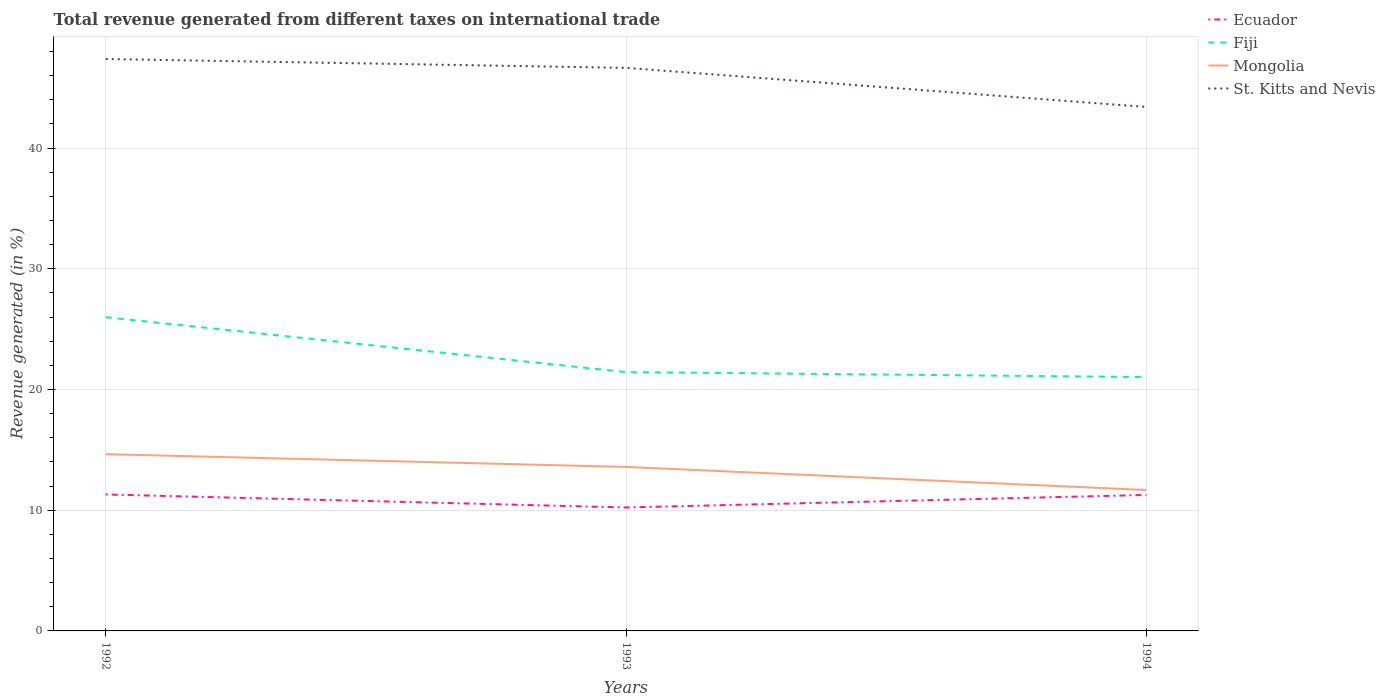How many different coloured lines are there?
Ensure brevity in your answer.  4. Does the line corresponding to St. Kitts and Nevis intersect with the line corresponding to Fiji?
Keep it short and to the point. No. Across all years, what is the maximum total revenue generated in Fiji?
Give a very brief answer. 21.03. What is the total total revenue generated in St. Kitts and Nevis in the graph?
Your answer should be compact. 3.24. What is the difference between the highest and the second highest total revenue generated in St. Kitts and Nevis?
Ensure brevity in your answer.  3.97. What is the difference between two consecutive major ticks on the Y-axis?
Your response must be concise. 10. Where does the legend appear in the graph?
Your answer should be compact. Top right. How many legend labels are there?
Give a very brief answer. 4. What is the title of the graph?
Make the answer very short. Total revenue generated from different taxes on international trade. Does "Kazakhstan" appear as one of the legend labels in the graph?
Provide a succinct answer. No. What is the label or title of the X-axis?
Offer a very short reply. Years. What is the label or title of the Y-axis?
Make the answer very short. Revenue generated (in %). What is the Revenue generated (in %) of Ecuador in 1992?
Make the answer very short. 11.3. What is the Revenue generated (in %) in Fiji in 1992?
Ensure brevity in your answer.  25.99. What is the Revenue generated (in %) in Mongolia in 1992?
Provide a succinct answer. 14.64. What is the Revenue generated (in %) in St. Kitts and Nevis in 1992?
Your response must be concise. 47.38. What is the Revenue generated (in %) of Ecuador in 1993?
Make the answer very short. 10.23. What is the Revenue generated (in %) in Fiji in 1993?
Give a very brief answer. 21.44. What is the Revenue generated (in %) in Mongolia in 1993?
Give a very brief answer. 13.59. What is the Revenue generated (in %) of St. Kitts and Nevis in 1993?
Your answer should be very brief. 46.64. What is the Revenue generated (in %) in Ecuador in 1994?
Your answer should be compact. 11.27. What is the Revenue generated (in %) of Fiji in 1994?
Your answer should be compact. 21.03. What is the Revenue generated (in %) in Mongolia in 1994?
Your answer should be very brief. 11.67. What is the Revenue generated (in %) in St. Kitts and Nevis in 1994?
Give a very brief answer. 43.41. Across all years, what is the maximum Revenue generated (in %) of Ecuador?
Your response must be concise. 11.3. Across all years, what is the maximum Revenue generated (in %) of Fiji?
Provide a succinct answer. 25.99. Across all years, what is the maximum Revenue generated (in %) in Mongolia?
Offer a very short reply. 14.64. Across all years, what is the maximum Revenue generated (in %) of St. Kitts and Nevis?
Offer a very short reply. 47.38. Across all years, what is the minimum Revenue generated (in %) in Ecuador?
Provide a succinct answer. 10.23. Across all years, what is the minimum Revenue generated (in %) in Fiji?
Make the answer very short. 21.03. Across all years, what is the minimum Revenue generated (in %) in Mongolia?
Ensure brevity in your answer.  11.67. Across all years, what is the minimum Revenue generated (in %) of St. Kitts and Nevis?
Provide a succinct answer. 43.41. What is the total Revenue generated (in %) in Ecuador in the graph?
Give a very brief answer. 32.8. What is the total Revenue generated (in %) in Fiji in the graph?
Offer a terse response. 68.46. What is the total Revenue generated (in %) in Mongolia in the graph?
Offer a terse response. 39.9. What is the total Revenue generated (in %) in St. Kitts and Nevis in the graph?
Your answer should be compact. 137.43. What is the difference between the Revenue generated (in %) of Ecuador in 1992 and that in 1993?
Ensure brevity in your answer.  1.08. What is the difference between the Revenue generated (in %) of Fiji in 1992 and that in 1993?
Ensure brevity in your answer.  4.55. What is the difference between the Revenue generated (in %) of Mongolia in 1992 and that in 1993?
Your answer should be compact. 1.06. What is the difference between the Revenue generated (in %) of St. Kitts and Nevis in 1992 and that in 1993?
Keep it short and to the point. 0.74. What is the difference between the Revenue generated (in %) of Ecuador in 1992 and that in 1994?
Offer a terse response. 0.04. What is the difference between the Revenue generated (in %) in Fiji in 1992 and that in 1994?
Provide a short and direct response. 4.96. What is the difference between the Revenue generated (in %) in Mongolia in 1992 and that in 1994?
Offer a very short reply. 2.97. What is the difference between the Revenue generated (in %) of St. Kitts and Nevis in 1992 and that in 1994?
Provide a succinct answer. 3.97. What is the difference between the Revenue generated (in %) in Ecuador in 1993 and that in 1994?
Provide a short and direct response. -1.04. What is the difference between the Revenue generated (in %) of Fiji in 1993 and that in 1994?
Offer a terse response. 0.41. What is the difference between the Revenue generated (in %) of Mongolia in 1993 and that in 1994?
Keep it short and to the point. 1.91. What is the difference between the Revenue generated (in %) of St. Kitts and Nevis in 1993 and that in 1994?
Provide a succinct answer. 3.24. What is the difference between the Revenue generated (in %) of Ecuador in 1992 and the Revenue generated (in %) of Fiji in 1993?
Keep it short and to the point. -10.14. What is the difference between the Revenue generated (in %) of Ecuador in 1992 and the Revenue generated (in %) of Mongolia in 1993?
Your answer should be very brief. -2.28. What is the difference between the Revenue generated (in %) in Ecuador in 1992 and the Revenue generated (in %) in St. Kitts and Nevis in 1993?
Make the answer very short. -35.34. What is the difference between the Revenue generated (in %) in Fiji in 1992 and the Revenue generated (in %) in Mongolia in 1993?
Keep it short and to the point. 12.4. What is the difference between the Revenue generated (in %) in Fiji in 1992 and the Revenue generated (in %) in St. Kitts and Nevis in 1993?
Your answer should be very brief. -20.65. What is the difference between the Revenue generated (in %) of Mongolia in 1992 and the Revenue generated (in %) of St. Kitts and Nevis in 1993?
Make the answer very short. -32. What is the difference between the Revenue generated (in %) in Ecuador in 1992 and the Revenue generated (in %) in Fiji in 1994?
Provide a succinct answer. -9.73. What is the difference between the Revenue generated (in %) in Ecuador in 1992 and the Revenue generated (in %) in Mongolia in 1994?
Provide a succinct answer. -0.37. What is the difference between the Revenue generated (in %) in Ecuador in 1992 and the Revenue generated (in %) in St. Kitts and Nevis in 1994?
Make the answer very short. -32.1. What is the difference between the Revenue generated (in %) of Fiji in 1992 and the Revenue generated (in %) of Mongolia in 1994?
Ensure brevity in your answer.  14.32. What is the difference between the Revenue generated (in %) in Fiji in 1992 and the Revenue generated (in %) in St. Kitts and Nevis in 1994?
Your response must be concise. -17.42. What is the difference between the Revenue generated (in %) of Mongolia in 1992 and the Revenue generated (in %) of St. Kitts and Nevis in 1994?
Provide a short and direct response. -28.76. What is the difference between the Revenue generated (in %) of Ecuador in 1993 and the Revenue generated (in %) of Fiji in 1994?
Give a very brief answer. -10.8. What is the difference between the Revenue generated (in %) in Ecuador in 1993 and the Revenue generated (in %) in Mongolia in 1994?
Your response must be concise. -1.45. What is the difference between the Revenue generated (in %) in Ecuador in 1993 and the Revenue generated (in %) in St. Kitts and Nevis in 1994?
Your response must be concise. -33.18. What is the difference between the Revenue generated (in %) of Fiji in 1993 and the Revenue generated (in %) of Mongolia in 1994?
Ensure brevity in your answer.  9.77. What is the difference between the Revenue generated (in %) in Fiji in 1993 and the Revenue generated (in %) in St. Kitts and Nevis in 1994?
Offer a terse response. -21.96. What is the difference between the Revenue generated (in %) in Mongolia in 1993 and the Revenue generated (in %) in St. Kitts and Nevis in 1994?
Provide a short and direct response. -29.82. What is the average Revenue generated (in %) of Ecuador per year?
Make the answer very short. 10.93. What is the average Revenue generated (in %) in Fiji per year?
Provide a short and direct response. 22.82. What is the average Revenue generated (in %) in Mongolia per year?
Give a very brief answer. 13.3. What is the average Revenue generated (in %) of St. Kitts and Nevis per year?
Offer a very short reply. 45.81. In the year 1992, what is the difference between the Revenue generated (in %) of Ecuador and Revenue generated (in %) of Fiji?
Your answer should be very brief. -14.69. In the year 1992, what is the difference between the Revenue generated (in %) in Ecuador and Revenue generated (in %) in Mongolia?
Make the answer very short. -3.34. In the year 1992, what is the difference between the Revenue generated (in %) in Ecuador and Revenue generated (in %) in St. Kitts and Nevis?
Provide a succinct answer. -36.07. In the year 1992, what is the difference between the Revenue generated (in %) of Fiji and Revenue generated (in %) of Mongolia?
Your answer should be compact. 11.35. In the year 1992, what is the difference between the Revenue generated (in %) of Fiji and Revenue generated (in %) of St. Kitts and Nevis?
Your response must be concise. -21.39. In the year 1992, what is the difference between the Revenue generated (in %) in Mongolia and Revenue generated (in %) in St. Kitts and Nevis?
Provide a short and direct response. -32.74. In the year 1993, what is the difference between the Revenue generated (in %) of Ecuador and Revenue generated (in %) of Fiji?
Make the answer very short. -11.22. In the year 1993, what is the difference between the Revenue generated (in %) in Ecuador and Revenue generated (in %) in Mongolia?
Ensure brevity in your answer.  -3.36. In the year 1993, what is the difference between the Revenue generated (in %) in Ecuador and Revenue generated (in %) in St. Kitts and Nevis?
Keep it short and to the point. -36.42. In the year 1993, what is the difference between the Revenue generated (in %) of Fiji and Revenue generated (in %) of Mongolia?
Your answer should be very brief. 7.86. In the year 1993, what is the difference between the Revenue generated (in %) in Fiji and Revenue generated (in %) in St. Kitts and Nevis?
Ensure brevity in your answer.  -25.2. In the year 1993, what is the difference between the Revenue generated (in %) in Mongolia and Revenue generated (in %) in St. Kitts and Nevis?
Provide a short and direct response. -33.06. In the year 1994, what is the difference between the Revenue generated (in %) in Ecuador and Revenue generated (in %) in Fiji?
Ensure brevity in your answer.  -9.76. In the year 1994, what is the difference between the Revenue generated (in %) in Ecuador and Revenue generated (in %) in Mongolia?
Your answer should be very brief. -0.41. In the year 1994, what is the difference between the Revenue generated (in %) of Ecuador and Revenue generated (in %) of St. Kitts and Nevis?
Make the answer very short. -32.14. In the year 1994, what is the difference between the Revenue generated (in %) in Fiji and Revenue generated (in %) in Mongolia?
Make the answer very short. 9.36. In the year 1994, what is the difference between the Revenue generated (in %) in Fiji and Revenue generated (in %) in St. Kitts and Nevis?
Provide a succinct answer. -22.38. In the year 1994, what is the difference between the Revenue generated (in %) in Mongolia and Revenue generated (in %) in St. Kitts and Nevis?
Offer a very short reply. -31.73. What is the ratio of the Revenue generated (in %) in Ecuador in 1992 to that in 1993?
Offer a terse response. 1.11. What is the ratio of the Revenue generated (in %) of Fiji in 1992 to that in 1993?
Your response must be concise. 1.21. What is the ratio of the Revenue generated (in %) in Mongolia in 1992 to that in 1993?
Offer a very short reply. 1.08. What is the ratio of the Revenue generated (in %) of St. Kitts and Nevis in 1992 to that in 1993?
Make the answer very short. 1.02. What is the ratio of the Revenue generated (in %) of Fiji in 1992 to that in 1994?
Offer a very short reply. 1.24. What is the ratio of the Revenue generated (in %) of Mongolia in 1992 to that in 1994?
Your answer should be compact. 1.25. What is the ratio of the Revenue generated (in %) in St. Kitts and Nevis in 1992 to that in 1994?
Provide a succinct answer. 1.09. What is the ratio of the Revenue generated (in %) of Ecuador in 1993 to that in 1994?
Provide a succinct answer. 0.91. What is the ratio of the Revenue generated (in %) in Fiji in 1993 to that in 1994?
Offer a very short reply. 1.02. What is the ratio of the Revenue generated (in %) of Mongolia in 1993 to that in 1994?
Give a very brief answer. 1.16. What is the ratio of the Revenue generated (in %) of St. Kitts and Nevis in 1993 to that in 1994?
Keep it short and to the point. 1.07. What is the difference between the highest and the second highest Revenue generated (in %) of Ecuador?
Give a very brief answer. 0.04. What is the difference between the highest and the second highest Revenue generated (in %) of Fiji?
Keep it short and to the point. 4.55. What is the difference between the highest and the second highest Revenue generated (in %) of Mongolia?
Make the answer very short. 1.06. What is the difference between the highest and the second highest Revenue generated (in %) in St. Kitts and Nevis?
Provide a short and direct response. 0.74. What is the difference between the highest and the lowest Revenue generated (in %) of Ecuador?
Provide a succinct answer. 1.08. What is the difference between the highest and the lowest Revenue generated (in %) in Fiji?
Offer a very short reply. 4.96. What is the difference between the highest and the lowest Revenue generated (in %) of Mongolia?
Ensure brevity in your answer.  2.97. What is the difference between the highest and the lowest Revenue generated (in %) in St. Kitts and Nevis?
Give a very brief answer. 3.97. 